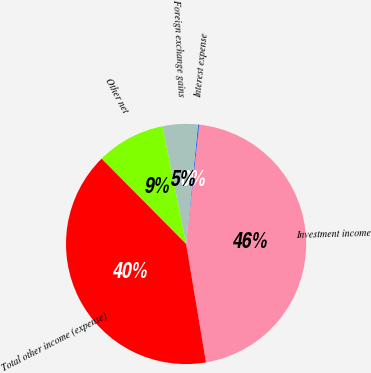<chart> <loc_0><loc_0><loc_500><loc_500><pie_chart><fcel>Investment income<fcel>Interest expense<fcel>Foreign exchange gains<fcel>Other net<fcel>Total other income (expense)<nl><fcel>45.59%<fcel>0.19%<fcel>4.73%<fcel>9.27%<fcel>40.23%<nl></chart> 